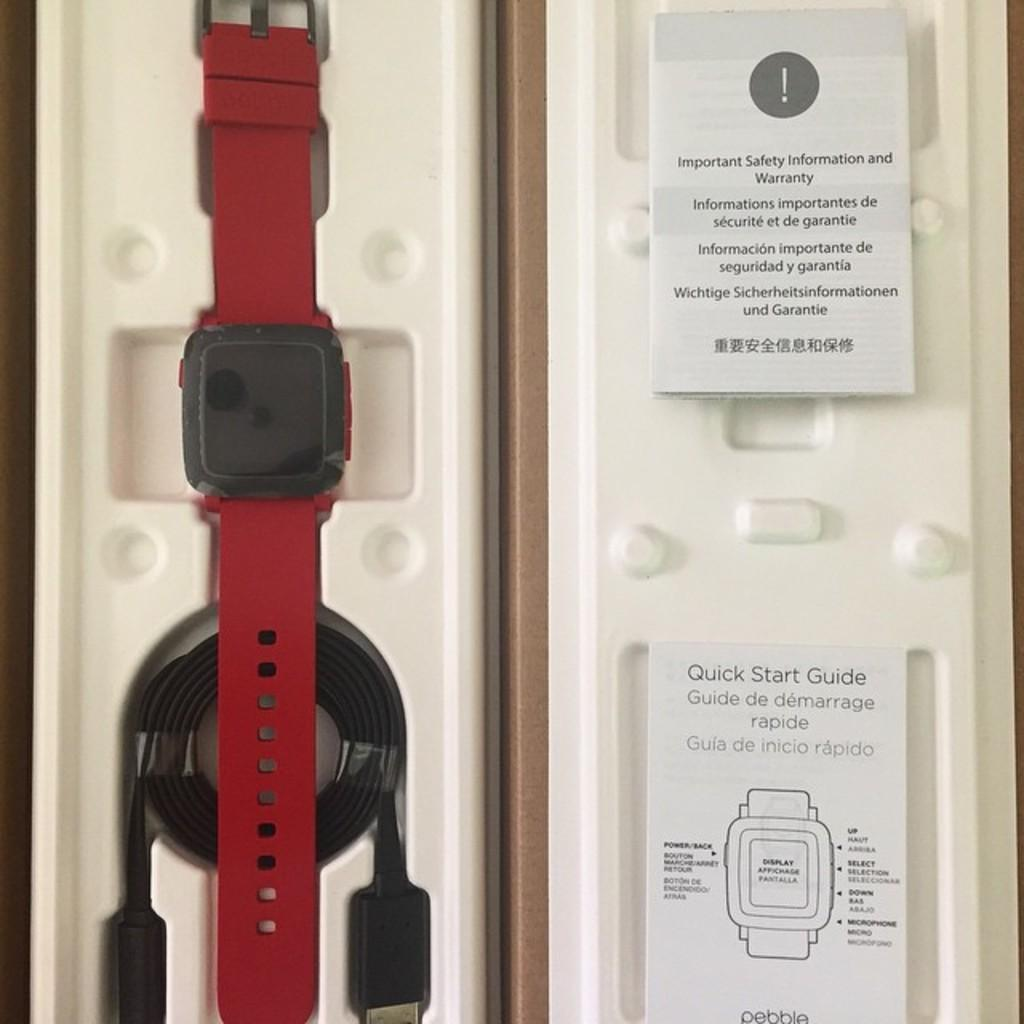<image>
Write a terse but informative summary of the picture. A red watch is in a case that includes a quick start guide. 